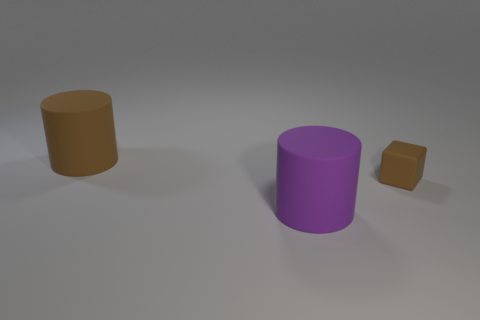Add 1 large purple rubber objects. How many objects exist? 4 Subtract all blocks. How many objects are left? 2 Add 2 small purple rubber cylinders. How many small purple rubber cylinders exist? 2 Subtract 0 brown spheres. How many objects are left? 3 Subtract all purple cylinders. Subtract all brown objects. How many objects are left? 0 Add 2 purple rubber objects. How many purple rubber objects are left? 3 